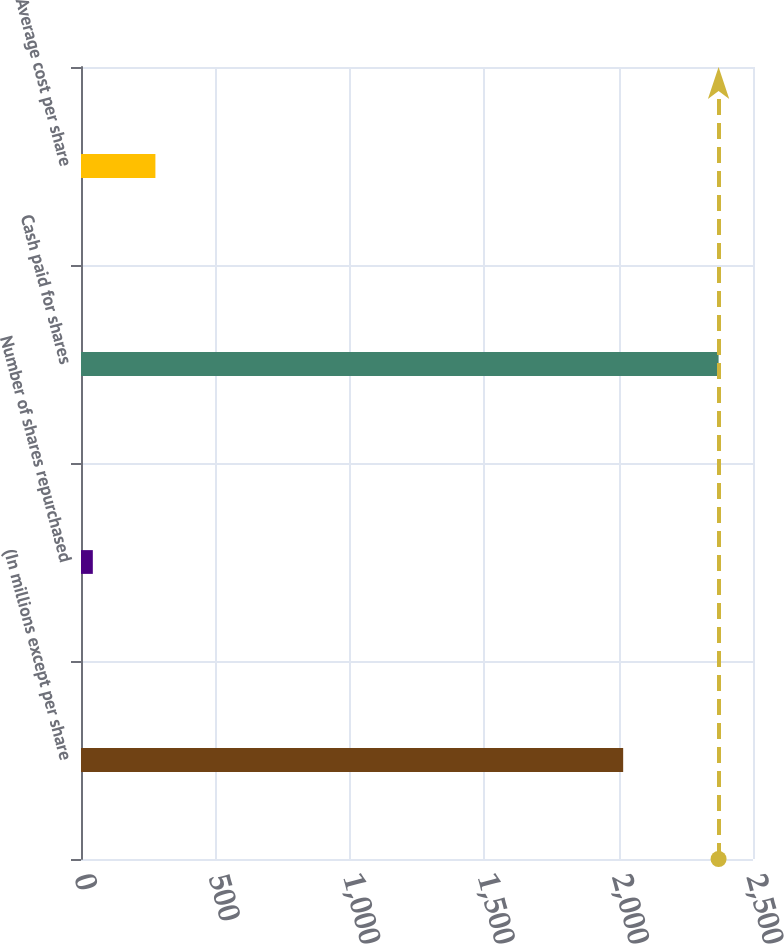Convert chart. <chart><loc_0><loc_0><loc_500><loc_500><bar_chart><fcel>(In millions except per share<fcel>Number of shares repurchased<fcel>Cash paid for shares<fcel>Average cost per share<nl><fcel>2017<fcel>44<fcel>2372<fcel>276.8<nl></chart> 